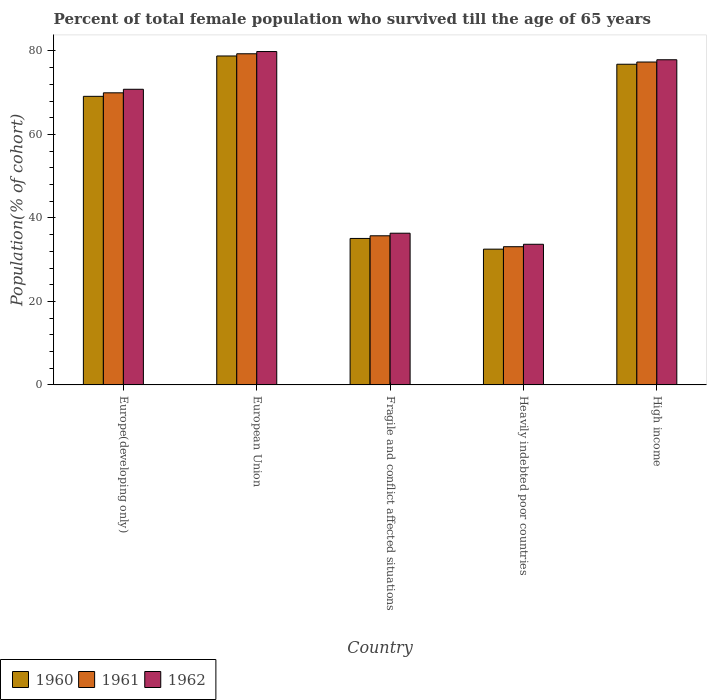How many different coloured bars are there?
Provide a short and direct response. 3. Are the number of bars on each tick of the X-axis equal?
Offer a very short reply. Yes. What is the label of the 1st group of bars from the left?
Keep it short and to the point. Europe(developing only). In how many cases, is the number of bars for a given country not equal to the number of legend labels?
Provide a short and direct response. 0. What is the percentage of total female population who survived till the age of 65 years in 1960 in Europe(developing only)?
Your answer should be compact. 69.12. Across all countries, what is the maximum percentage of total female population who survived till the age of 65 years in 1960?
Your response must be concise. 78.79. Across all countries, what is the minimum percentage of total female population who survived till the age of 65 years in 1962?
Give a very brief answer. 33.69. In which country was the percentage of total female population who survived till the age of 65 years in 1960 minimum?
Offer a terse response. Heavily indebted poor countries. What is the total percentage of total female population who survived till the age of 65 years in 1962 in the graph?
Your response must be concise. 298.58. What is the difference between the percentage of total female population who survived till the age of 65 years in 1962 in European Union and that in Fragile and conflict affected situations?
Ensure brevity in your answer.  43.51. What is the difference between the percentage of total female population who survived till the age of 65 years in 1961 in European Union and the percentage of total female population who survived till the age of 65 years in 1960 in Fragile and conflict affected situations?
Ensure brevity in your answer.  44.24. What is the average percentage of total female population who survived till the age of 65 years in 1960 per country?
Provide a succinct answer. 58.47. What is the difference between the percentage of total female population who survived till the age of 65 years of/in 1962 and percentage of total female population who survived till the age of 65 years of/in 1961 in High income?
Ensure brevity in your answer.  0.54. In how many countries, is the percentage of total female population who survived till the age of 65 years in 1962 greater than 64 %?
Offer a very short reply. 3. What is the ratio of the percentage of total female population who survived till the age of 65 years in 1960 in European Union to that in Heavily indebted poor countries?
Offer a very short reply. 2.42. What is the difference between the highest and the second highest percentage of total female population who survived till the age of 65 years in 1962?
Make the answer very short. 7.07. What is the difference between the highest and the lowest percentage of total female population who survived till the age of 65 years in 1960?
Your response must be concise. 46.27. What does the 1st bar from the left in High income represents?
Your response must be concise. 1960. What does the 1st bar from the right in Heavily indebted poor countries represents?
Give a very brief answer. 1962. Are all the bars in the graph horizontal?
Provide a short and direct response. No. How many countries are there in the graph?
Your response must be concise. 5. Are the values on the major ticks of Y-axis written in scientific E-notation?
Your response must be concise. No. Does the graph contain grids?
Your answer should be compact. No. What is the title of the graph?
Your response must be concise. Percent of total female population who survived till the age of 65 years. Does "1983" appear as one of the legend labels in the graph?
Your response must be concise. No. What is the label or title of the Y-axis?
Make the answer very short. Population(% of cohort). What is the Population(% of cohort) in 1960 in Europe(developing only)?
Keep it short and to the point. 69.12. What is the Population(% of cohort) in 1961 in Europe(developing only)?
Provide a short and direct response. 69.97. What is the Population(% of cohort) in 1962 in Europe(developing only)?
Your response must be concise. 70.82. What is the Population(% of cohort) in 1960 in European Union?
Your response must be concise. 78.79. What is the Population(% of cohort) of 1961 in European Union?
Your response must be concise. 79.32. What is the Population(% of cohort) in 1962 in European Union?
Make the answer very short. 79.85. What is the Population(% of cohort) in 1960 in Fragile and conflict affected situations?
Your response must be concise. 35.08. What is the Population(% of cohort) in 1961 in Fragile and conflict affected situations?
Make the answer very short. 35.72. What is the Population(% of cohort) in 1962 in Fragile and conflict affected situations?
Your answer should be very brief. 36.34. What is the Population(% of cohort) in 1960 in Heavily indebted poor countries?
Your answer should be compact. 32.52. What is the Population(% of cohort) of 1961 in Heavily indebted poor countries?
Make the answer very short. 33.1. What is the Population(% of cohort) of 1962 in Heavily indebted poor countries?
Your answer should be very brief. 33.69. What is the Population(% of cohort) of 1960 in High income?
Your answer should be very brief. 76.81. What is the Population(% of cohort) in 1961 in High income?
Ensure brevity in your answer.  77.34. What is the Population(% of cohort) in 1962 in High income?
Offer a terse response. 77.88. Across all countries, what is the maximum Population(% of cohort) of 1960?
Provide a succinct answer. 78.79. Across all countries, what is the maximum Population(% of cohort) in 1961?
Give a very brief answer. 79.32. Across all countries, what is the maximum Population(% of cohort) of 1962?
Make the answer very short. 79.85. Across all countries, what is the minimum Population(% of cohort) of 1960?
Your response must be concise. 32.52. Across all countries, what is the minimum Population(% of cohort) of 1961?
Give a very brief answer. 33.1. Across all countries, what is the minimum Population(% of cohort) of 1962?
Provide a succinct answer. 33.69. What is the total Population(% of cohort) in 1960 in the graph?
Provide a short and direct response. 292.33. What is the total Population(% of cohort) in 1961 in the graph?
Provide a succinct answer. 295.45. What is the total Population(% of cohort) in 1962 in the graph?
Your answer should be very brief. 298.58. What is the difference between the Population(% of cohort) in 1960 in Europe(developing only) and that in European Union?
Offer a very short reply. -9.67. What is the difference between the Population(% of cohort) of 1961 in Europe(developing only) and that in European Union?
Offer a very short reply. -9.35. What is the difference between the Population(% of cohort) in 1962 in Europe(developing only) and that in European Union?
Keep it short and to the point. -9.04. What is the difference between the Population(% of cohort) in 1960 in Europe(developing only) and that in Fragile and conflict affected situations?
Make the answer very short. 34.04. What is the difference between the Population(% of cohort) of 1961 in Europe(developing only) and that in Fragile and conflict affected situations?
Provide a succinct answer. 34.25. What is the difference between the Population(% of cohort) in 1962 in Europe(developing only) and that in Fragile and conflict affected situations?
Make the answer very short. 34.48. What is the difference between the Population(% of cohort) in 1960 in Europe(developing only) and that in Heavily indebted poor countries?
Provide a succinct answer. 36.6. What is the difference between the Population(% of cohort) of 1961 in Europe(developing only) and that in Heavily indebted poor countries?
Offer a terse response. 36.86. What is the difference between the Population(% of cohort) in 1962 in Europe(developing only) and that in Heavily indebted poor countries?
Offer a very short reply. 37.13. What is the difference between the Population(% of cohort) of 1960 in Europe(developing only) and that in High income?
Make the answer very short. -7.69. What is the difference between the Population(% of cohort) of 1961 in Europe(developing only) and that in High income?
Make the answer very short. -7.38. What is the difference between the Population(% of cohort) in 1962 in Europe(developing only) and that in High income?
Ensure brevity in your answer.  -7.07. What is the difference between the Population(% of cohort) in 1960 in European Union and that in Fragile and conflict affected situations?
Offer a very short reply. 43.71. What is the difference between the Population(% of cohort) of 1961 in European Union and that in Fragile and conflict affected situations?
Provide a succinct answer. 43.6. What is the difference between the Population(% of cohort) in 1962 in European Union and that in Fragile and conflict affected situations?
Ensure brevity in your answer.  43.51. What is the difference between the Population(% of cohort) of 1960 in European Union and that in Heavily indebted poor countries?
Give a very brief answer. 46.27. What is the difference between the Population(% of cohort) of 1961 in European Union and that in Heavily indebted poor countries?
Provide a succinct answer. 46.22. What is the difference between the Population(% of cohort) of 1962 in European Union and that in Heavily indebted poor countries?
Give a very brief answer. 46.17. What is the difference between the Population(% of cohort) of 1960 in European Union and that in High income?
Provide a short and direct response. 1.98. What is the difference between the Population(% of cohort) of 1961 in European Union and that in High income?
Your answer should be very brief. 1.98. What is the difference between the Population(% of cohort) of 1962 in European Union and that in High income?
Keep it short and to the point. 1.97. What is the difference between the Population(% of cohort) in 1960 in Fragile and conflict affected situations and that in Heavily indebted poor countries?
Give a very brief answer. 2.56. What is the difference between the Population(% of cohort) in 1961 in Fragile and conflict affected situations and that in Heavily indebted poor countries?
Ensure brevity in your answer.  2.61. What is the difference between the Population(% of cohort) of 1962 in Fragile and conflict affected situations and that in Heavily indebted poor countries?
Provide a succinct answer. 2.65. What is the difference between the Population(% of cohort) of 1960 in Fragile and conflict affected situations and that in High income?
Keep it short and to the point. -41.73. What is the difference between the Population(% of cohort) of 1961 in Fragile and conflict affected situations and that in High income?
Keep it short and to the point. -41.62. What is the difference between the Population(% of cohort) of 1962 in Fragile and conflict affected situations and that in High income?
Your answer should be very brief. -41.55. What is the difference between the Population(% of cohort) of 1960 in Heavily indebted poor countries and that in High income?
Offer a terse response. -44.29. What is the difference between the Population(% of cohort) of 1961 in Heavily indebted poor countries and that in High income?
Keep it short and to the point. -44.24. What is the difference between the Population(% of cohort) in 1962 in Heavily indebted poor countries and that in High income?
Your response must be concise. -44.2. What is the difference between the Population(% of cohort) of 1960 in Europe(developing only) and the Population(% of cohort) of 1961 in European Union?
Make the answer very short. -10.2. What is the difference between the Population(% of cohort) in 1960 in Europe(developing only) and the Population(% of cohort) in 1962 in European Union?
Offer a terse response. -10.73. What is the difference between the Population(% of cohort) in 1961 in Europe(developing only) and the Population(% of cohort) in 1962 in European Union?
Your response must be concise. -9.89. What is the difference between the Population(% of cohort) of 1960 in Europe(developing only) and the Population(% of cohort) of 1961 in Fragile and conflict affected situations?
Ensure brevity in your answer.  33.4. What is the difference between the Population(% of cohort) of 1960 in Europe(developing only) and the Population(% of cohort) of 1962 in Fragile and conflict affected situations?
Your answer should be very brief. 32.79. What is the difference between the Population(% of cohort) of 1961 in Europe(developing only) and the Population(% of cohort) of 1962 in Fragile and conflict affected situations?
Give a very brief answer. 33.63. What is the difference between the Population(% of cohort) in 1960 in Europe(developing only) and the Population(% of cohort) in 1961 in Heavily indebted poor countries?
Make the answer very short. 36.02. What is the difference between the Population(% of cohort) in 1960 in Europe(developing only) and the Population(% of cohort) in 1962 in Heavily indebted poor countries?
Keep it short and to the point. 35.44. What is the difference between the Population(% of cohort) of 1961 in Europe(developing only) and the Population(% of cohort) of 1962 in Heavily indebted poor countries?
Ensure brevity in your answer.  36.28. What is the difference between the Population(% of cohort) in 1960 in Europe(developing only) and the Population(% of cohort) in 1961 in High income?
Provide a short and direct response. -8.22. What is the difference between the Population(% of cohort) of 1960 in Europe(developing only) and the Population(% of cohort) of 1962 in High income?
Give a very brief answer. -8.76. What is the difference between the Population(% of cohort) in 1961 in Europe(developing only) and the Population(% of cohort) in 1962 in High income?
Provide a short and direct response. -7.92. What is the difference between the Population(% of cohort) in 1960 in European Union and the Population(% of cohort) in 1961 in Fragile and conflict affected situations?
Your response must be concise. 43.07. What is the difference between the Population(% of cohort) in 1960 in European Union and the Population(% of cohort) in 1962 in Fragile and conflict affected situations?
Make the answer very short. 42.45. What is the difference between the Population(% of cohort) in 1961 in European Union and the Population(% of cohort) in 1962 in Fragile and conflict affected situations?
Give a very brief answer. 42.98. What is the difference between the Population(% of cohort) in 1960 in European Union and the Population(% of cohort) in 1961 in Heavily indebted poor countries?
Your answer should be compact. 45.69. What is the difference between the Population(% of cohort) in 1960 in European Union and the Population(% of cohort) in 1962 in Heavily indebted poor countries?
Keep it short and to the point. 45.1. What is the difference between the Population(% of cohort) of 1961 in European Union and the Population(% of cohort) of 1962 in Heavily indebted poor countries?
Provide a succinct answer. 45.63. What is the difference between the Population(% of cohort) in 1960 in European Union and the Population(% of cohort) in 1961 in High income?
Give a very brief answer. 1.45. What is the difference between the Population(% of cohort) of 1960 in European Union and the Population(% of cohort) of 1962 in High income?
Ensure brevity in your answer.  0.9. What is the difference between the Population(% of cohort) of 1961 in European Union and the Population(% of cohort) of 1962 in High income?
Your answer should be compact. 1.44. What is the difference between the Population(% of cohort) of 1960 in Fragile and conflict affected situations and the Population(% of cohort) of 1961 in Heavily indebted poor countries?
Offer a terse response. 1.98. What is the difference between the Population(% of cohort) in 1960 in Fragile and conflict affected situations and the Population(% of cohort) in 1962 in Heavily indebted poor countries?
Ensure brevity in your answer.  1.4. What is the difference between the Population(% of cohort) of 1961 in Fragile and conflict affected situations and the Population(% of cohort) of 1962 in Heavily indebted poor countries?
Keep it short and to the point. 2.03. What is the difference between the Population(% of cohort) in 1960 in Fragile and conflict affected situations and the Population(% of cohort) in 1961 in High income?
Your answer should be compact. -42.26. What is the difference between the Population(% of cohort) in 1960 in Fragile and conflict affected situations and the Population(% of cohort) in 1962 in High income?
Offer a terse response. -42.8. What is the difference between the Population(% of cohort) in 1961 in Fragile and conflict affected situations and the Population(% of cohort) in 1962 in High income?
Provide a succinct answer. -42.17. What is the difference between the Population(% of cohort) of 1960 in Heavily indebted poor countries and the Population(% of cohort) of 1961 in High income?
Your answer should be compact. -44.82. What is the difference between the Population(% of cohort) in 1960 in Heavily indebted poor countries and the Population(% of cohort) in 1962 in High income?
Offer a terse response. -45.36. What is the difference between the Population(% of cohort) in 1961 in Heavily indebted poor countries and the Population(% of cohort) in 1962 in High income?
Offer a terse response. -44.78. What is the average Population(% of cohort) in 1960 per country?
Give a very brief answer. 58.47. What is the average Population(% of cohort) of 1961 per country?
Provide a succinct answer. 59.09. What is the average Population(% of cohort) in 1962 per country?
Your response must be concise. 59.72. What is the difference between the Population(% of cohort) of 1960 and Population(% of cohort) of 1961 in Europe(developing only)?
Give a very brief answer. -0.84. What is the difference between the Population(% of cohort) of 1960 and Population(% of cohort) of 1962 in Europe(developing only)?
Your answer should be compact. -1.69. What is the difference between the Population(% of cohort) of 1961 and Population(% of cohort) of 1962 in Europe(developing only)?
Your answer should be compact. -0.85. What is the difference between the Population(% of cohort) of 1960 and Population(% of cohort) of 1961 in European Union?
Your answer should be compact. -0.53. What is the difference between the Population(% of cohort) of 1960 and Population(% of cohort) of 1962 in European Union?
Keep it short and to the point. -1.06. What is the difference between the Population(% of cohort) in 1961 and Population(% of cohort) in 1962 in European Union?
Make the answer very short. -0.53. What is the difference between the Population(% of cohort) of 1960 and Population(% of cohort) of 1961 in Fragile and conflict affected situations?
Keep it short and to the point. -0.63. What is the difference between the Population(% of cohort) of 1960 and Population(% of cohort) of 1962 in Fragile and conflict affected situations?
Provide a succinct answer. -1.25. What is the difference between the Population(% of cohort) of 1961 and Population(% of cohort) of 1962 in Fragile and conflict affected situations?
Offer a very short reply. -0.62. What is the difference between the Population(% of cohort) in 1960 and Population(% of cohort) in 1961 in Heavily indebted poor countries?
Give a very brief answer. -0.58. What is the difference between the Population(% of cohort) of 1960 and Population(% of cohort) of 1962 in Heavily indebted poor countries?
Your answer should be very brief. -1.17. What is the difference between the Population(% of cohort) of 1961 and Population(% of cohort) of 1962 in Heavily indebted poor countries?
Ensure brevity in your answer.  -0.58. What is the difference between the Population(% of cohort) in 1960 and Population(% of cohort) in 1961 in High income?
Offer a very short reply. -0.53. What is the difference between the Population(% of cohort) of 1960 and Population(% of cohort) of 1962 in High income?
Your answer should be very brief. -1.07. What is the difference between the Population(% of cohort) of 1961 and Population(% of cohort) of 1962 in High income?
Your response must be concise. -0.54. What is the ratio of the Population(% of cohort) in 1960 in Europe(developing only) to that in European Union?
Provide a short and direct response. 0.88. What is the ratio of the Population(% of cohort) in 1961 in Europe(developing only) to that in European Union?
Your response must be concise. 0.88. What is the ratio of the Population(% of cohort) in 1962 in Europe(developing only) to that in European Union?
Provide a succinct answer. 0.89. What is the ratio of the Population(% of cohort) of 1960 in Europe(developing only) to that in Fragile and conflict affected situations?
Ensure brevity in your answer.  1.97. What is the ratio of the Population(% of cohort) in 1961 in Europe(developing only) to that in Fragile and conflict affected situations?
Provide a succinct answer. 1.96. What is the ratio of the Population(% of cohort) in 1962 in Europe(developing only) to that in Fragile and conflict affected situations?
Your answer should be compact. 1.95. What is the ratio of the Population(% of cohort) in 1960 in Europe(developing only) to that in Heavily indebted poor countries?
Your answer should be compact. 2.13. What is the ratio of the Population(% of cohort) in 1961 in Europe(developing only) to that in Heavily indebted poor countries?
Your answer should be compact. 2.11. What is the ratio of the Population(% of cohort) of 1962 in Europe(developing only) to that in Heavily indebted poor countries?
Your answer should be compact. 2.1. What is the ratio of the Population(% of cohort) of 1960 in Europe(developing only) to that in High income?
Provide a short and direct response. 0.9. What is the ratio of the Population(% of cohort) in 1961 in Europe(developing only) to that in High income?
Offer a terse response. 0.9. What is the ratio of the Population(% of cohort) in 1962 in Europe(developing only) to that in High income?
Offer a very short reply. 0.91. What is the ratio of the Population(% of cohort) of 1960 in European Union to that in Fragile and conflict affected situations?
Give a very brief answer. 2.25. What is the ratio of the Population(% of cohort) in 1961 in European Union to that in Fragile and conflict affected situations?
Keep it short and to the point. 2.22. What is the ratio of the Population(% of cohort) in 1962 in European Union to that in Fragile and conflict affected situations?
Your response must be concise. 2.2. What is the ratio of the Population(% of cohort) of 1960 in European Union to that in Heavily indebted poor countries?
Keep it short and to the point. 2.42. What is the ratio of the Population(% of cohort) of 1961 in European Union to that in Heavily indebted poor countries?
Ensure brevity in your answer.  2.4. What is the ratio of the Population(% of cohort) of 1962 in European Union to that in Heavily indebted poor countries?
Your response must be concise. 2.37. What is the ratio of the Population(% of cohort) in 1960 in European Union to that in High income?
Provide a short and direct response. 1.03. What is the ratio of the Population(% of cohort) in 1961 in European Union to that in High income?
Your answer should be very brief. 1.03. What is the ratio of the Population(% of cohort) in 1962 in European Union to that in High income?
Your answer should be very brief. 1.03. What is the ratio of the Population(% of cohort) in 1960 in Fragile and conflict affected situations to that in Heavily indebted poor countries?
Make the answer very short. 1.08. What is the ratio of the Population(% of cohort) in 1961 in Fragile and conflict affected situations to that in Heavily indebted poor countries?
Offer a very short reply. 1.08. What is the ratio of the Population(% of cohort) in 1962 in Fragile and conflict affected situations to that in Heavily indebted poor countries?
Your answer should be compact. 1.08. What is the ratio of the Population(% of cohort) of 1960 in Fragile and conflict affected situations to that in High income?
Your response must be concise. 0.46. What is the ratio of the Population(% of cohort) of 1961 in Fragile and conflict affected situations to that in High income?
Your answer should be compact. 0.46. What is the ratio of the Population(% of cohort) of 1962 in Fragile and conflict affected situations to that in High income?
Give a very brief answer. 0.47. What is the ratio of the Population(% of cohort) of 1960 in Heavily indebted poor countries to that in High income?
Make the answer very short. 0.42. What is the ratio of the Population(% of cohort) in 1961 in Heavily indebted poor countries to that in High income?
Offer a very short reply. 0.43. What is the ratio of the Population(% of cohort) of 1962 in Heavily indebted poor countries to that in High income?
Offer a very short reply. 0.43. What is the difference between the highest and the second highest Population(% of cohort) of 1960?
Provide a succinct answer. 1.98. What is the difference between the highest and the second highest Population(% of cohort) of 1961?
Provide a short and direct response. 1.98. What is the difference between the highest and the second highest Population(% of cohort) in 1962?
Provide a succinct answer. 1.97. What is the difference between the highest and the lowest Population(% of cohort) in 1960?
Provide a succinct answer. 46.27. What is the difference between the highest and the lowest Population(% of cohort) in 1961?
Your answer should be compact. 46.22. What is the difference between the highest and the lowest Population(% of cohort) in 1962?
Make the answer very short. 46.17. 